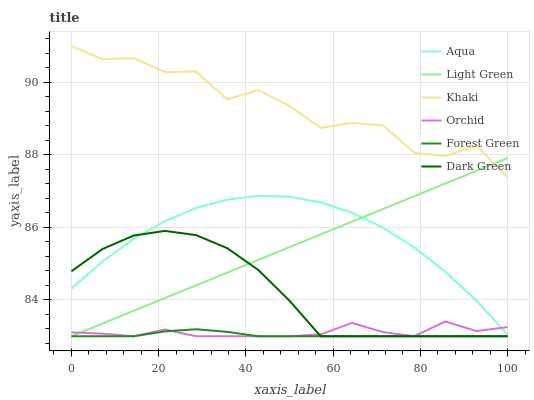Does Forest Green have the minimum area under the curve?
Answer yes or no. Yes. Does Khaki have the maximum area under the curve?
Answer yes or no. Yes. Does Aqua have the minimum area under the curve?
Answer yes or no. No. Does Aqua have the maximum area under the curve?
Answer yes or no. No. Is Light Green the smoothest?
Answer yes or no. Yes. Is Khaki the roughest?
Answer yes or no. Yes. Is Aqua the smoothest?
Answer yes or no. No. Is Aqua the roughest?
Answer yes or no. No. Does Forest Green have the lowest value?
Answer yes or no. Yes. Does Aqua have the lowest value?
Answer yes or no. No. Does Khaki have the highest value?
Answer yes or no. Yes. Does Aqua have the highest value?
Answer yes or no. No. Is Dark Green less than Khaki?
Answer yes or no. Yes. Is Khaki greater than Aqua?
Answer yes or no. Yes. Does Forest Green intersect Orchid?
Answer yes or no. Yes. Is Forest Green less than Orchid?
Answer yes or no. No. Is Forest Green greater than Orchid?
Answer yes or no. No. Does Dark Green intersect Khaki?
Answer yes or no. No. 